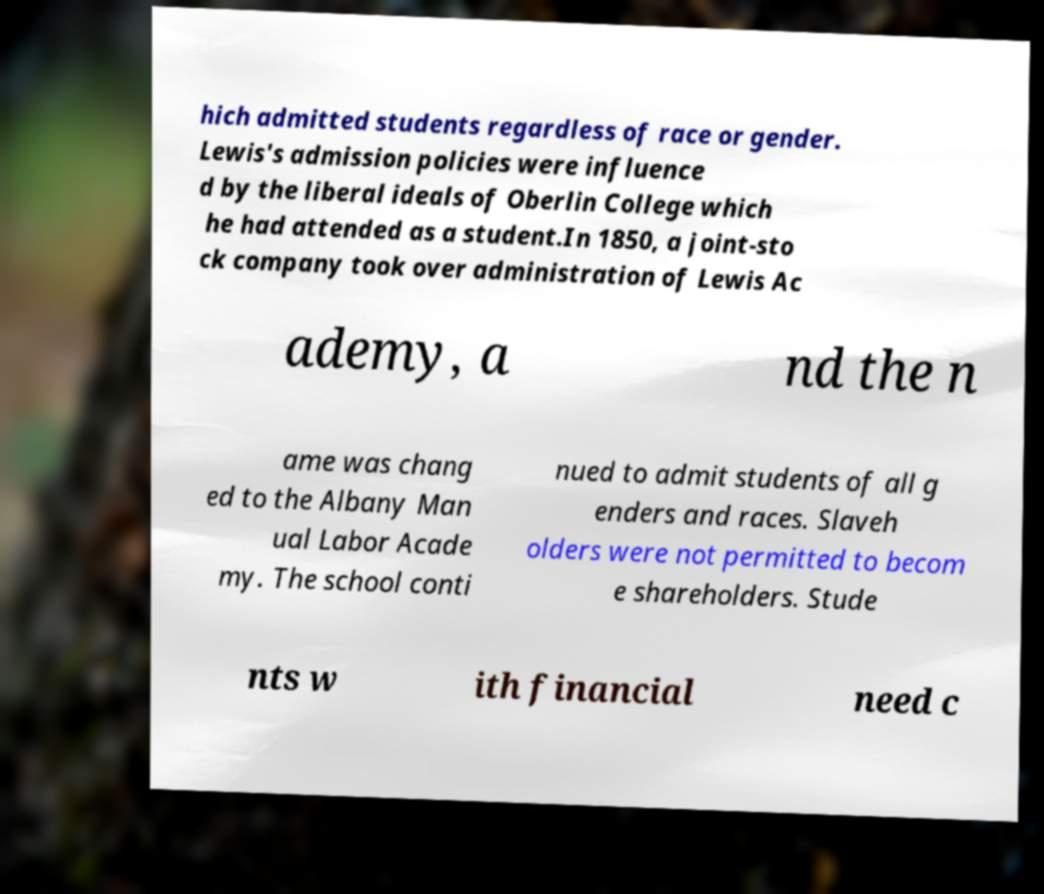There's text embedded in this image that I need extracted. Can you transcribe it verbatim? hich admitted students regardless of race or gender. Lewis's admission policies were influence d by the liberal ideals of Oberlin College which he had attended as a student.In 1850, a joint-sto ck company took over administration of Lewis Ac ademy, a nd the n ame was chang ed to the Albany Man ual Labor Acade my. The school conti nued to admit students of all g enders and races. Slaveh olders were not permitted to becom e shareholders. Stude nts w ith financial need c 